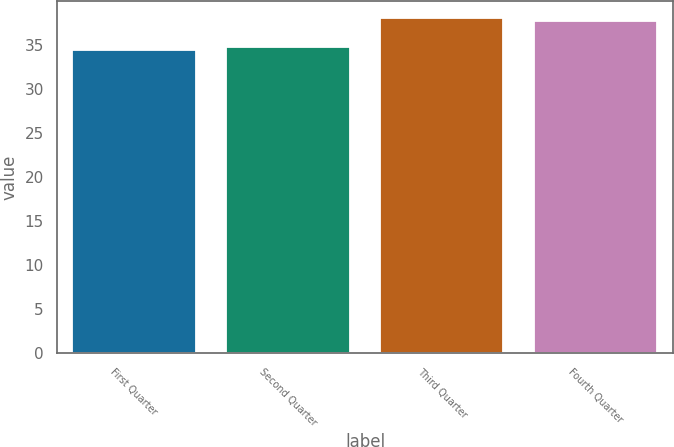Convert chart to OTSL. <chart><loc_0><loc_0><loc_500><loc_500><bar_chart><fcel>First Quarter<fcel>Second Quarter<fcel>Third Quarter<fcel>Fourth Quarter<nl><fcel>34.37<fcel>34.74<fcel>38.05<fcel>37.65<nl></chart> 